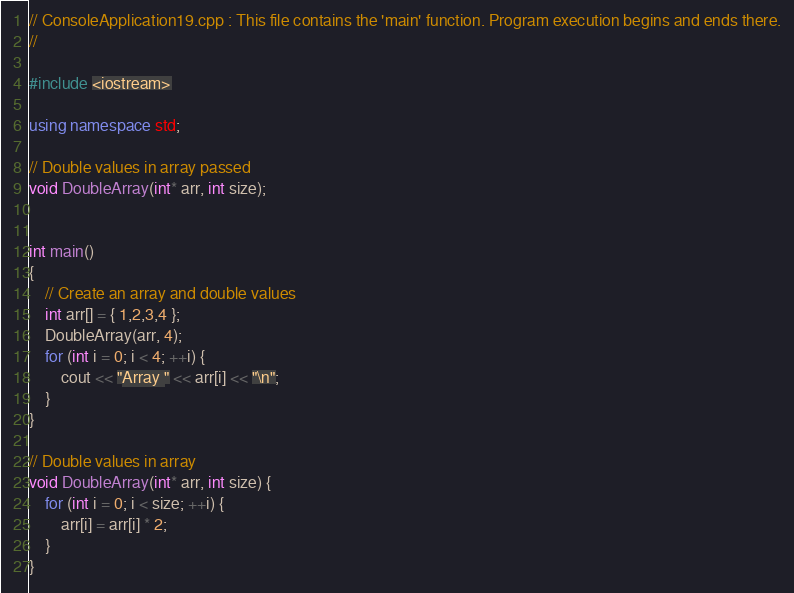Convert code to text. <code><loc_0><loc_0><loc_500><loc_500><_C++_>// ConsoleApplication19.cpp : This file contains the 'main' function. Program execution begins and ends there.
//

#include <iostream>

using namespace std;

// Double values in array passed
void DoubleArray(int* arr, int size);


int main()
{
    // Create an array and double values
    int arr[] = { 1,2,3,4 };
    DoubleArray(arr, 4);
    for (int i = 0; i < 4; ++i) {
        cout << "Array " << arr[i] << "\n";
    }
}

// Double values in array
void DoubleArray(int* arr, int size) {
    for (int i = 0; i < size; ++i) {
        arr[i] = arr[i] * 2;
    }
}</code> 